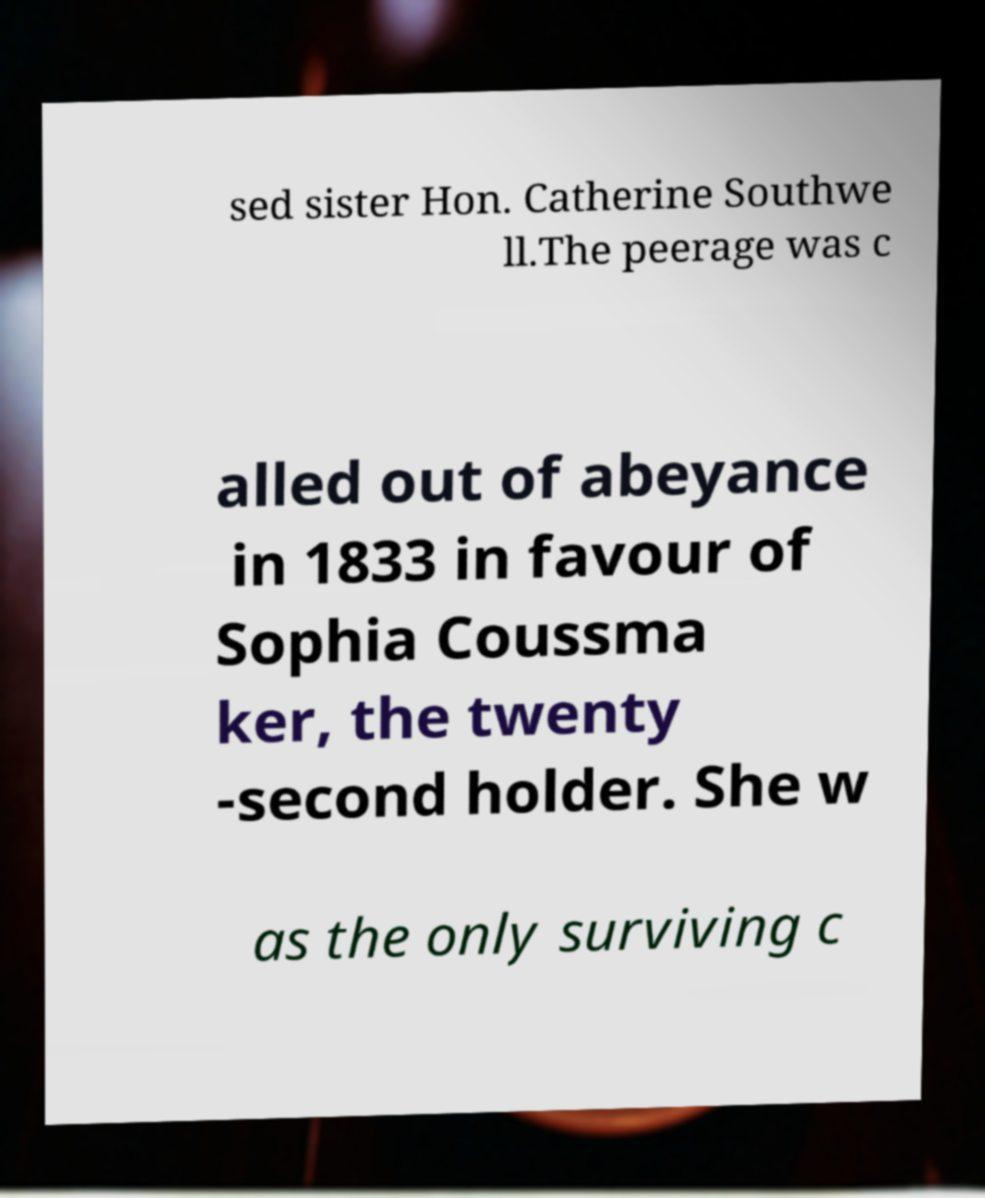Can you accurately transcribe the text from the provided image for me? sed sister Hon. Catherine Southwe ll.The peerage was c alled out of abeyance in 1833 in favour of Sophia Coussma ker, the twenty -second holder. She w as the only surviving c 